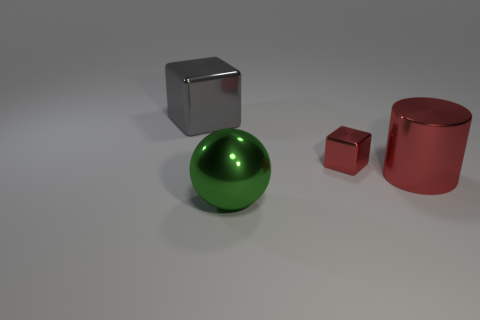Add 4 cyan shiny balls. How many objects exist? 8 Subtract all cylinders. How many objects are left? 3 Add 4 big gray objects. How many big gray objects are left? 5 Add 3 big metal spheres. How many big metal spheres exist? 4 Subtract 0 cyan balls. How many objects are left? 4 Subtract all small yellow metal cylinders. Subtract all big objects. How many objects are left? 1 